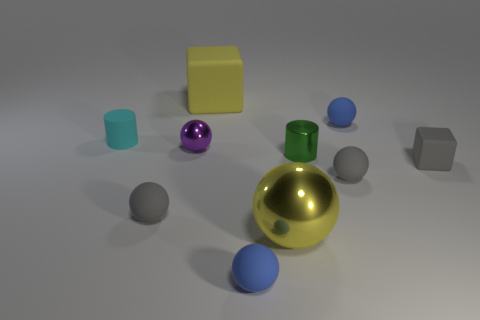Subtract 2 balls. How many balls are left? 4 Subtract all purple cylinders. How many blue spheres are left? 2 Subtract all yellow spheres. How many spheres are left? 5 Subtract all big balls. How many balls are left? 5 Subtract all blue balls. Subtract all red cubes. How many balls are left? 4 Subtract all balls. How many objects are left? 4 Subtract 0 cyan balls. How many objects are left? 10 Subtract all big metal balls. Subtract all gray cylinders. How many objects are left? 9 Add 2 tiny blue things. How many tiny blue things are left? 4 Add 1 tiny yellow balls. How many tiny yellow balls exist? 1 